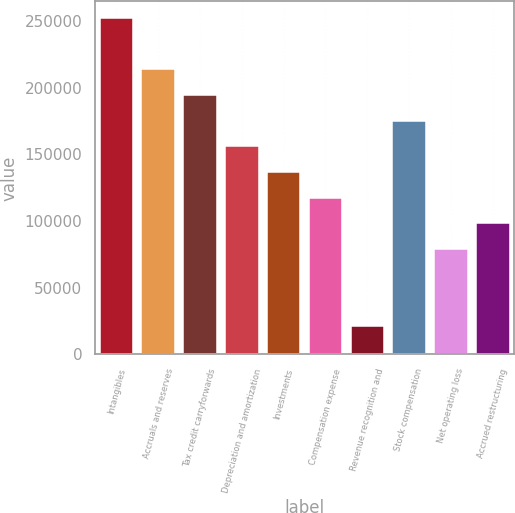Convert chart to OTSL. <chart><loc_0><loc_0><loc_500><loc_500><bar_chart><fcel>Intangibles<fcel>Accruals and reserves<fcel>Tax credit carryforwards<fcel>Depreciation and amortization<fcel>Investments<fcel>Compensation expense<fcel>Revenue recognition and<fcel>Stock compensation<fcel>Net operating loss<fcel>Accrued restructuring<nl><fcel>252312<fcel>213818<fcel>194571<fcel>156077<fcel>136830<fcel>117583<fcel>21348.9<fcel>175324<fcel>79089.6<fcel>98336.5<nl></chart> 